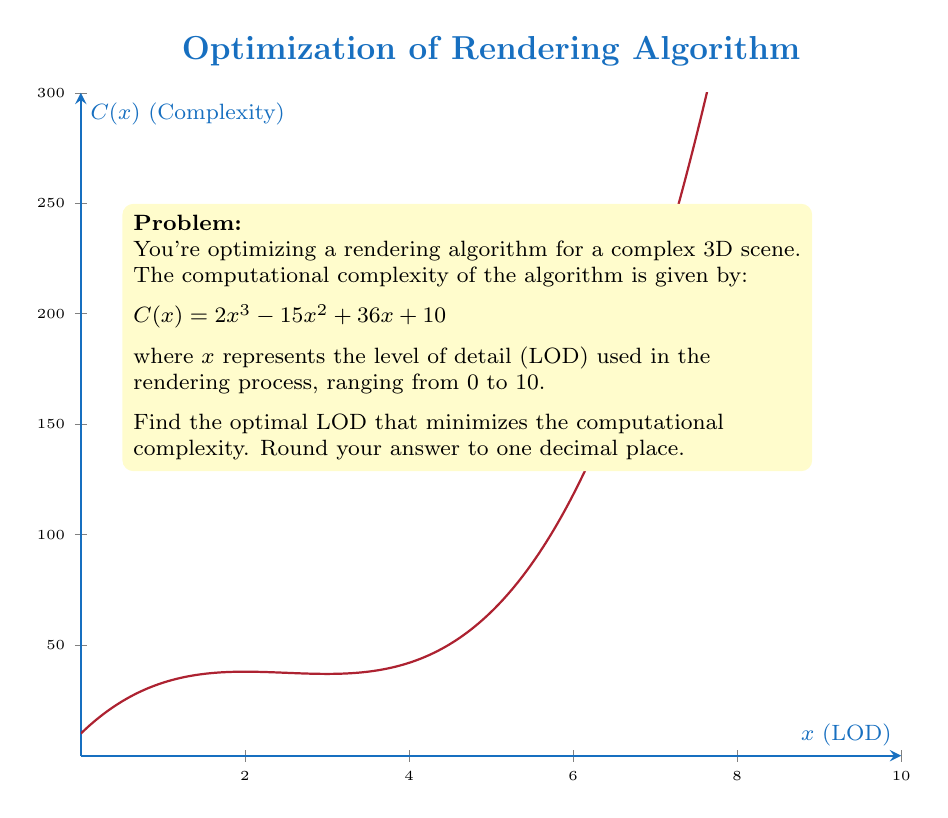Teach me how to tackle this problem. To find the optimal LOD that minimizes computational complexity, we need to find the minimum point of the function $C(x)$. This can be done by finding where the derivative of $C(x)$ equals zero.

Step 1: Calculate the derivative of $C(x)$
$$C'(x) = 6x^2 - 30x + 36$$

Step 2: Set the derivative equal to zero and solve for x
$$6x^2 - 30x + 36 = 0$$

Step 3: This is a quadratic equation. We can solve it using the quadratic formula:
$$x = \frac{-b \pm \sqrt{b^2 - 4ac}}{2a}$$
where $a=6$, $b=-30$, and $c=36$

$$x = \frac{30 \pm \sqrt{(-30)^2 - 4(6)(36)}}{2(6)}$$
$$x = \frac{30 \pm \sqrt{900 - 864}}{12}$$
$$x = \frac{30 \pm \sqrt{36}}{12}$$
$$x = \frac{30 \pm 6}{12}$$

Step 4: This gives us two solutions:
$$x_1 = \frac{30 + 6}{12} = 3$$
$$x_2 = \frac{30 - 6}{12} = 2$$

Step 5: To determine which solution gives the minimum, we can check the second derivative:
$$C''(x) = 12x - 30$$

At $x = 3$: $C''(3) = 12(3) - 30 = 6 > 0$, indicating a local minimum.
At $x = 2$: $C''(2) = 12(2) - 30 = -6 < 0$, indicating a local maximum.

Therefore, the optimal LOD that minimizes computational complexity is 3.

Since the question asks to round to one decimal place, the final answer is 3.0.
Answer: 3.0 